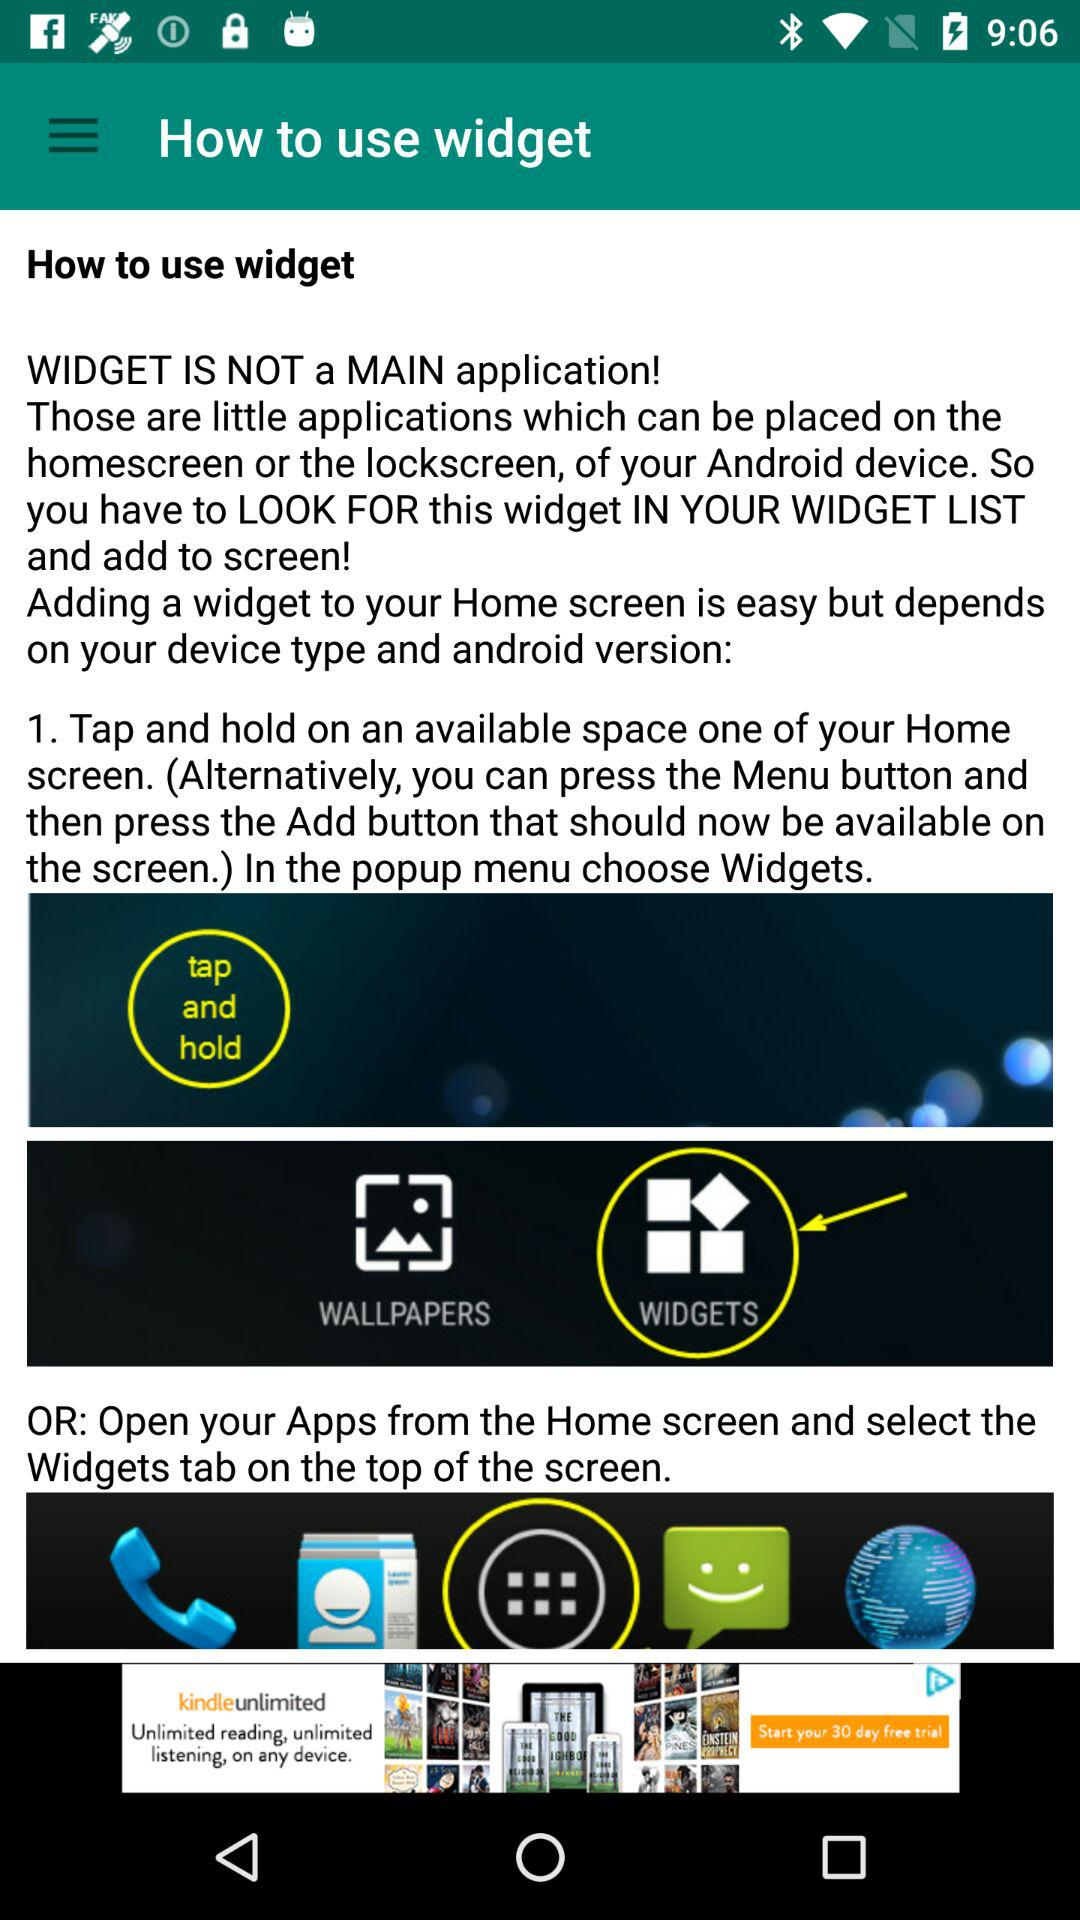What does adding a widget to the home screen depend on? Adding a widget to the home screen depends on device type and Android version. 